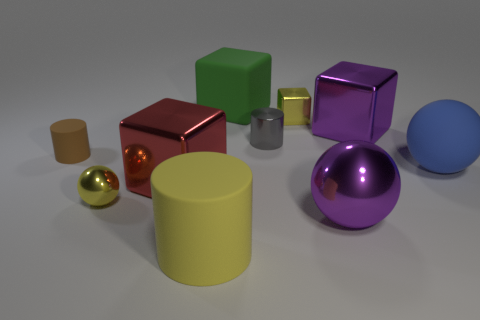What materials do these objects appear to be made of? The objects in the image exhibit different surface properties suggesting varying materials. The spheres and cubes have shiny surfaces indicating they might be metallic, while the cylinders seem to have matte finishes, which could mean they are made of plastic or another non-reflective material. 